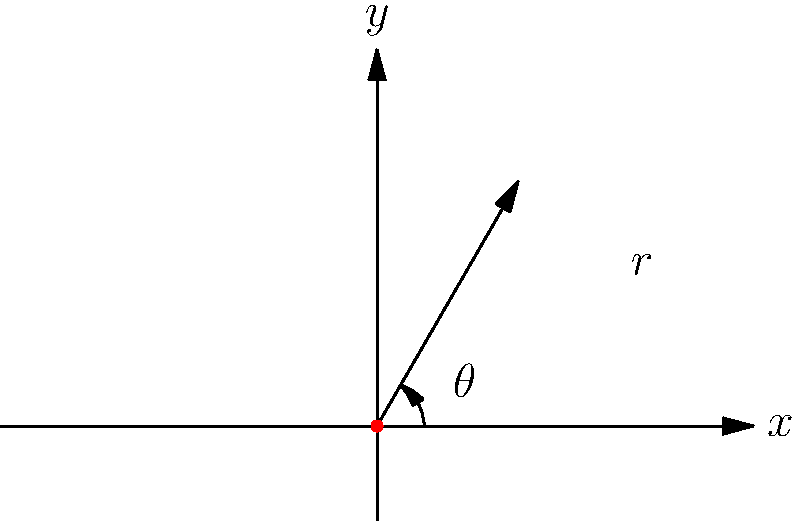In a 2D video game, you're designing a projectile launch system. The projectile's initial position is represented in polar coordinates as $(r, \theta)$, where $r = 3$ units and $\theta$ is the angle from the positive x-axis. If the projectile's trajectory makes an angle of 60° with the positive x-axis, what is the value of $\theta$ in radians? Let's approach this step-by-step:

1) In polar coordinates, $\theta$ represents the angle between the positive x-axis and the line from the origin to the point $(r, \theta)$.

2) We're told that the projectile's trajectory makes an angle of 60° with the positive x-axis.

3) In this case, the trajectory angle is exactly the same as $\theta$ in the polar coordinate system.

4) We need to convert 60° to radians. The formula for this conversion is:

   $\theta \text{ (in radians)} = \frac{\theta \text{ (in degrees)} \times \pi}{180°}$

5) Plugging in our value:

   $\theta = \frac{60° \times \pi}{180°} = \frac{\pi}{3}$ radians

6) Therefore, the polar coordinates of the projectile's initial position are $(3, \frac{\pi}{3})$.

Remember, as a newbie competitor, it's important to practice these conversions as they're often crucial in game physics calculations!
Answer: $\frac{\pi}{3}$ radians 